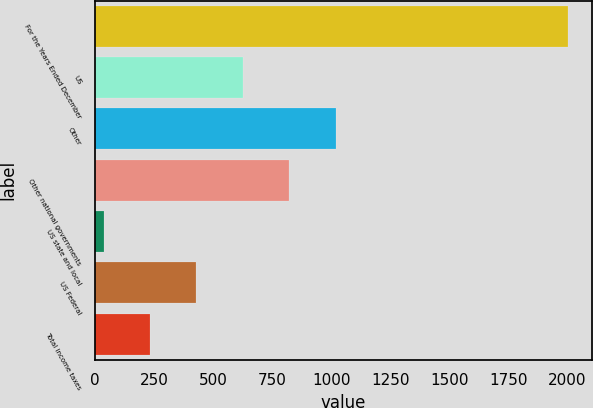Convert chart to OTSL. <chart><loc_0><loc_0><loc_500><loc_500><bar_chart><fcel>For the Years Ended December<fcel>US<fcel>Other<fcel>Other national governments<fcel>US state and local<fcel>US Federal<fcel>Total income taxes<nl><fcel>2005<fcel>626<fcel>1020<fcel>823<fcel>35<fcel>429<fcel>232<nl></chart> 